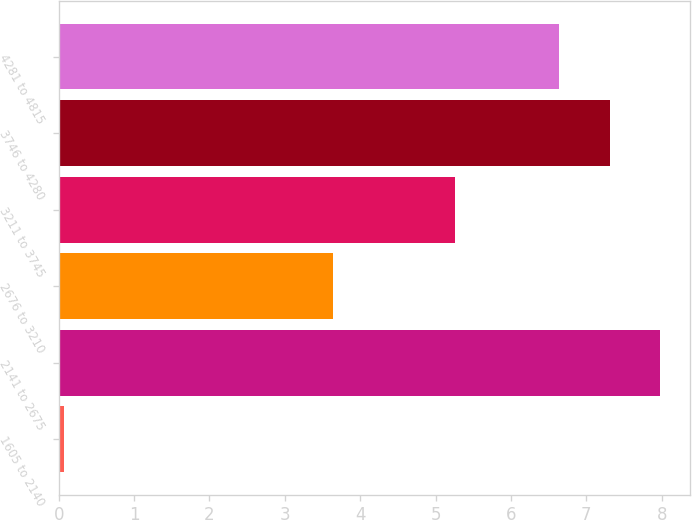Convert chart. <chart><loc_0><loc_0><loc_500><loc_500><bar_chart><fcel>1605 to 2140<fcel>2141 to 2675<fcel>2676 to 3210<fcel>3211 to 3745<fcel>3746 to 4280<fcel>4281 to 4815<nl><fcel>0.07<fcel>7.98<fcel>3.64<fcel>5.26<fcel>7.31<fcel>6.64<nl></chart> 